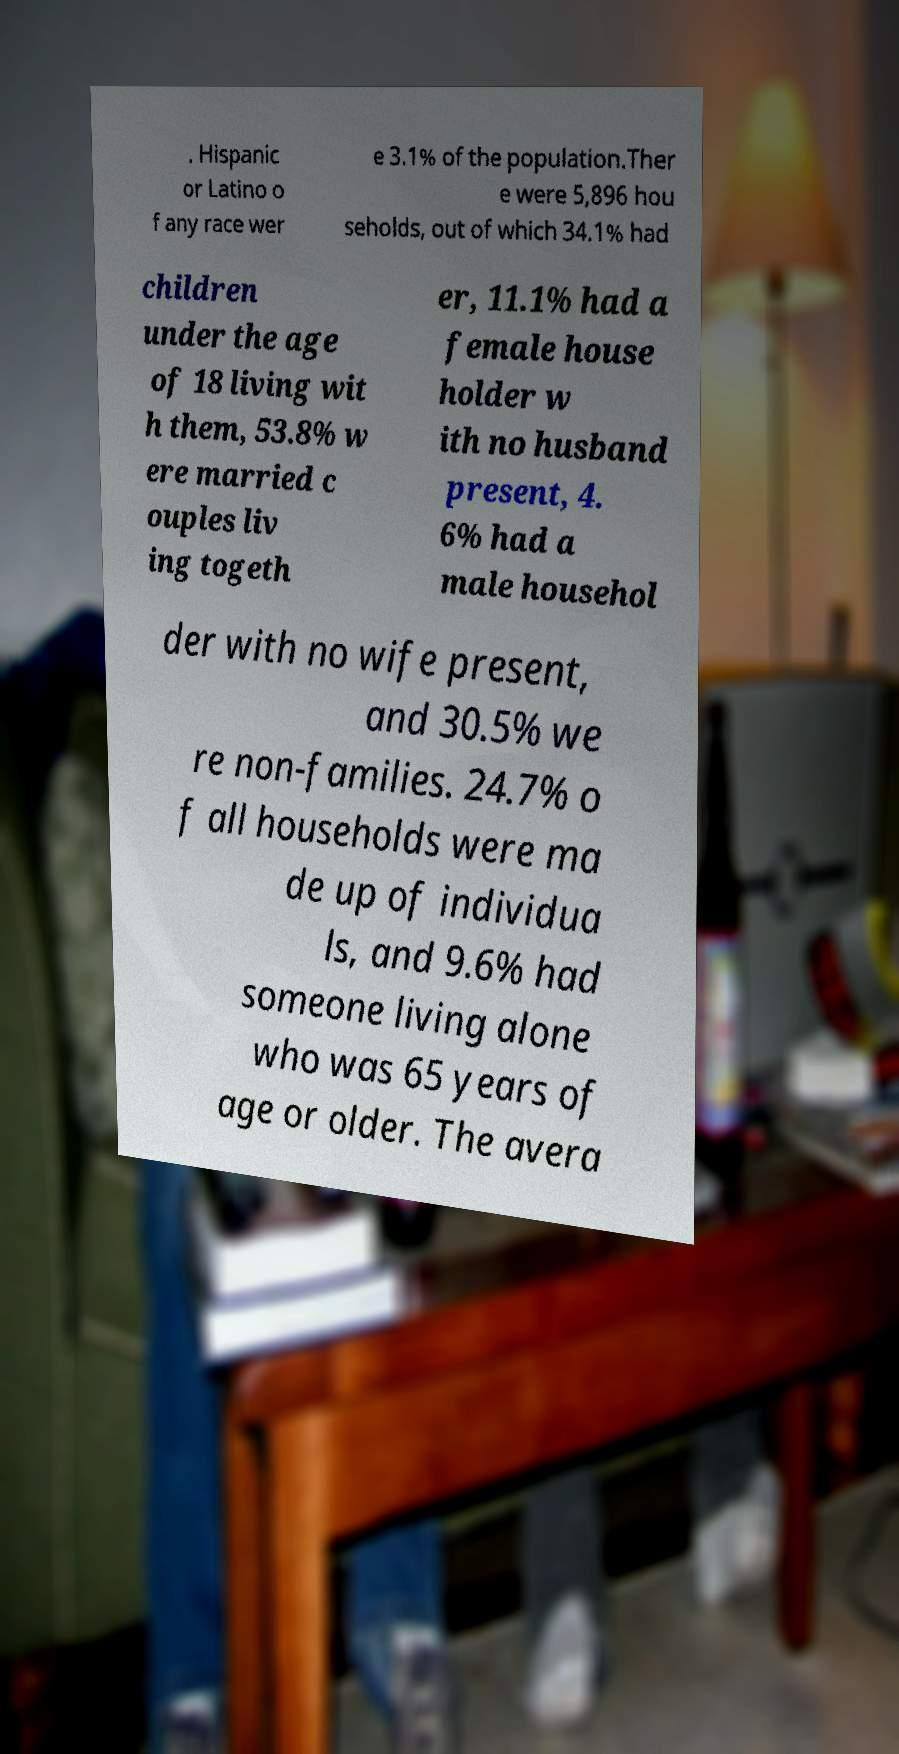For documentation purposes, I need the text within this image transcribed. Could you provide that? . Hispanic or Latino o f any race wer e 3.1% of the population.Ther e were 5,896 hou seholds, out of which 34.1% had children under the age of 18 living wit h them, 53.8% w ere married c ouples liv ing togeth er, 11.1% had a female house holder w ith no husband present, 4. 6% had a male househol der with no wife present, and 30.5% we re non-families. 24.7% o f all households were ma de up of individua ls, and 9.6% had someone living alone who was 65 years of age or older. The avera 